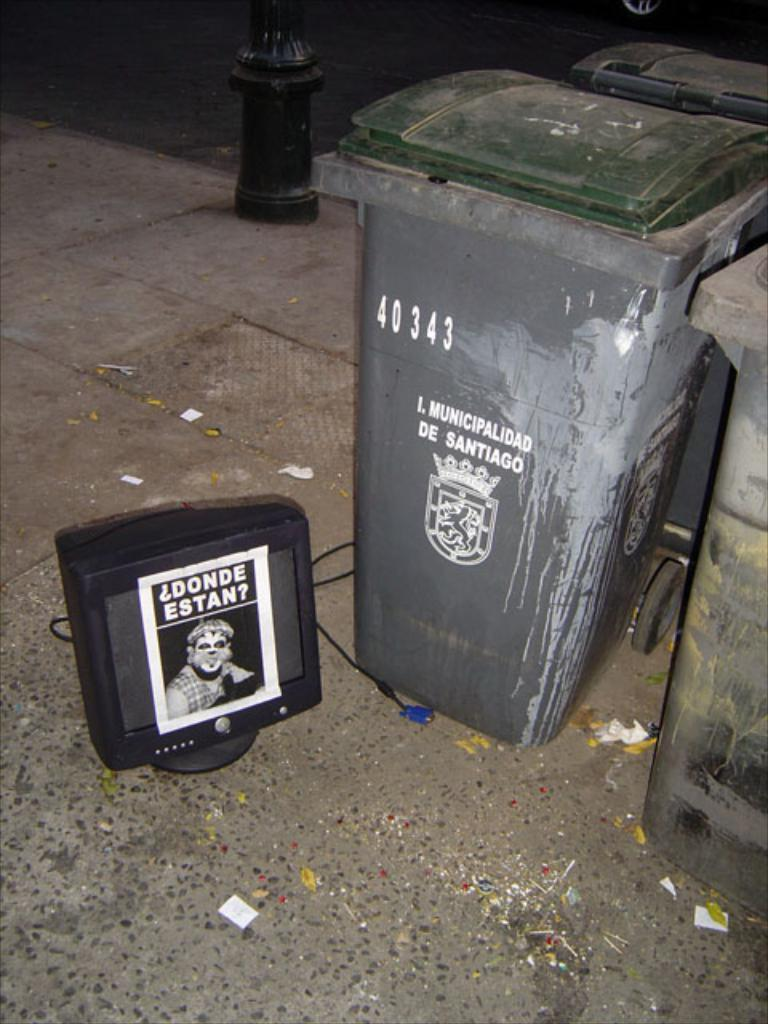Provide a one-sentence caption for the provided image. Garbage can which has the numbers 40343 on it. 